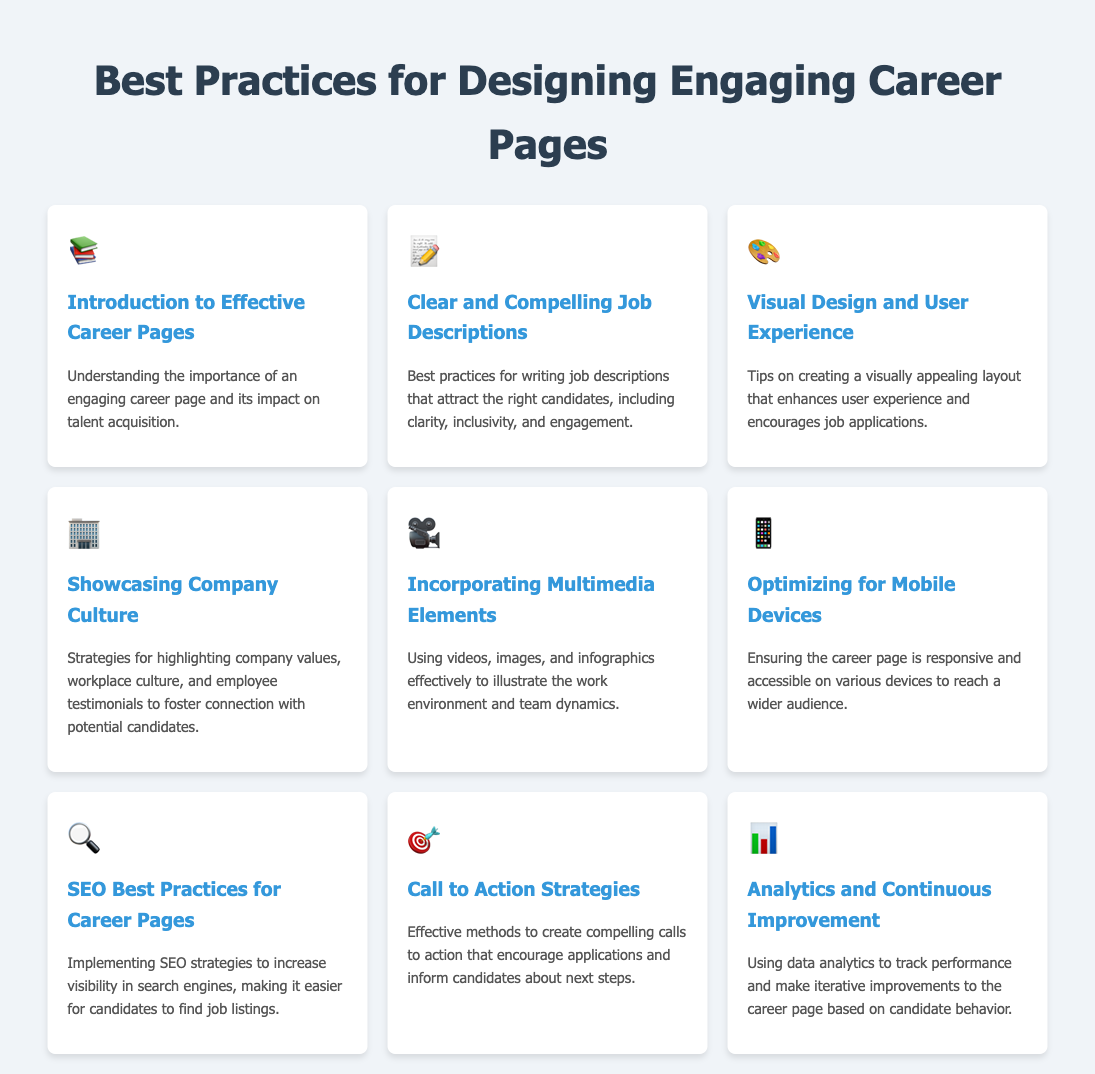What is the title of the document? The title of the document is mentioned in the <title> tag, indicating the topic of discussion.
Answer: Best Practices for Designing Engaging Career Pages How many menu items are listed in the document? The document contains several menu items, each representing a different aspect of career page best practices.
Answer: 9 Which icon represents the section on optimizing for mobile devices? The document specifies a unique icon for each menu item, and the icon in question is associated with the corresponding section.
Answer: 📱 What is highlighted in the section on showcasing company culture? The section focuses on specific elements that foster a connection between the company and potential candidates.
Answer: company values, workplace culture, and employee testimonials What does the section on analytics emphasize? The purpose of the analytics section is to provide insights into improving the career page based on specific metrics.
Answer: track performance and make iterative improvements What is the main focus of the 'Clear and Compelling Job Descriptions' section? This section outlines how to craft job descriptions that align with strategic goals for attracting quality candidates.
Answer: attract the right candidates What multimedia elements are suggested for incorporation? The document discusses different types of multimedia that can enhance the engagement of the career page content.
Answer: videos, images, and infographics What is a key strategy mentioned in the document for increasing visibility in search engines? The document includes a section detailing practices to improve the discoverability of job listings in online searches.
Answer: SEO strategies What type of design does the document recommend for enhancing user experience? The document advises on elements that can create a visually appealing experience for job seekers on the career page.
Answer: visually appealing layout 